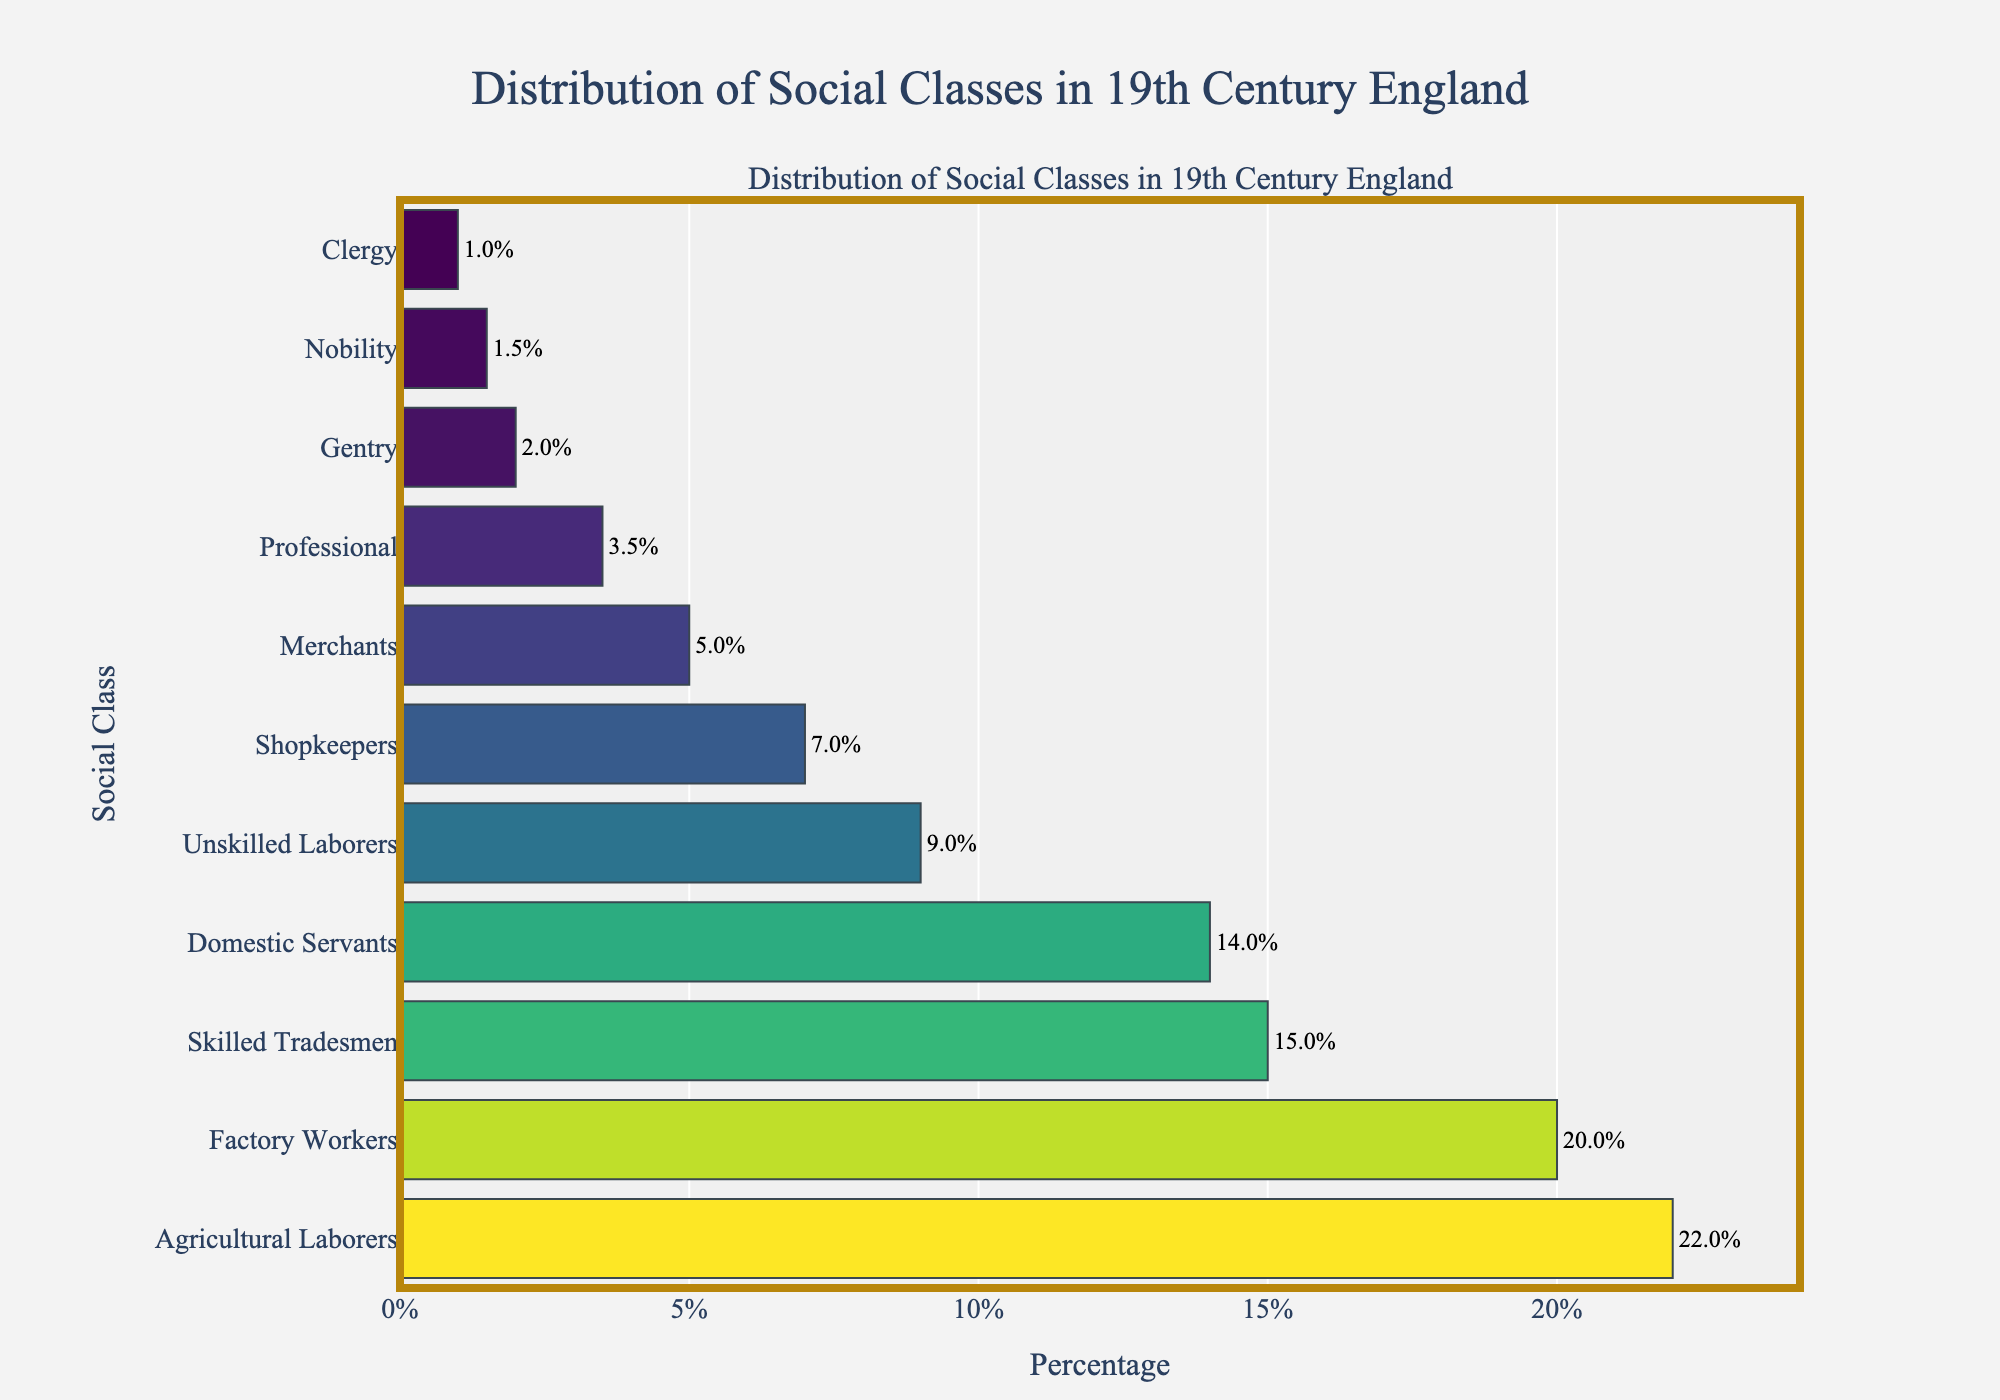Which social class had the highest percentage in the 19th century England? The class with the highest percentage is depicted by the longest bar in the figure. By examining the lengths of the bars, Agricultural Laborers have the longest bar.
Answer: Agricultural Laborers How much higher is the percentage of Factory Workers compared to Clergy? The figure shows Factory Workers at 20.0% and Clergy at 1.0%. The difference is calculated as 20.0% - 1.0%.
Answer: 19% Which two social classes have the closest percentages? The closest percentages can be found by visually comparing the length of the bars. Nobility is 1.5% and Clergy 1.0%. Gentry is 2.0% and Professional 3.5%. The smallest difference is between Nobility and Clergy, with a difference of 0.5%.
Answer: Nobility and Clergy What percentage of the population were either Nobility or Gentry? Adding the percentages for Nobility (1.5%) and Gentry (2.0%) gives 1.5% + 2.0%.
Answer: 3.5% What is the combined percentage of Skilled Tradesmen, Factory Workers, and Domestic Servants? Adding the percentages for Skilled Tradesmen (15.0%), Factory Workers (20.0%), and Domestic Servants (14.0%) results in 15.0% + 20.0% + 14.0%.
Answer: 49% Which social class has a percentage closest to 10%? By examining the figure, Unskilled Laborers have a percentage of 9.0%, which is closest to 10%.
Answer: Unskilled Laborers Are there more Agricultural Laborers or Merchants in the 19th century England? The figure shows Agricultural Laborers at 22.0% and Merchants at 5.0%. Comparing the two values, Agricultural Laborers have a higher percentage.
Answer: Agricultural Laborers What percentage of the population worked in occupations related to trade (Merchants and Shopkeepers)? Adding the percentages for Merchants (5.0%) and Shopkeepers (7.0%) gives 5.0% + 7.0%.
Answer: 12% What is the difference in percentage between the highest and lowest social classes represented in the figure? The highest percentage is Agricultural Laborers at 22.0% and the lowest is Clergy at 1.0%. The difference is calculated as 22.0% - 1.0%.
Answer: 21% How much larger is the percentage of Agricultural Laborers compared to Professional workers? The percentage for Agricultural Laborers is 22.0% and for Professional workers is 3.5%. The difference is 22.0% - 3.5%.
Answer: 18.5% 